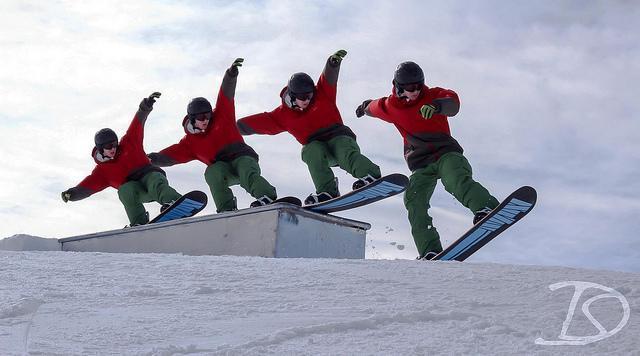How many people are there?
Give a very brief answer. 4. How many birds have red on their head?
Give a very brief answer. 0. 